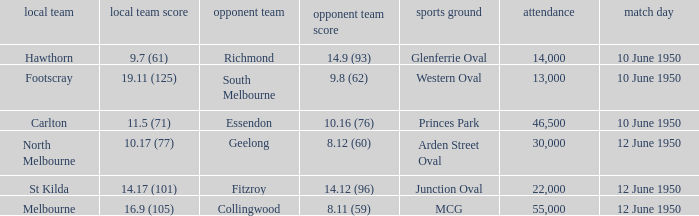Who was the away team when the VFL played at MCG? Collingwood. 